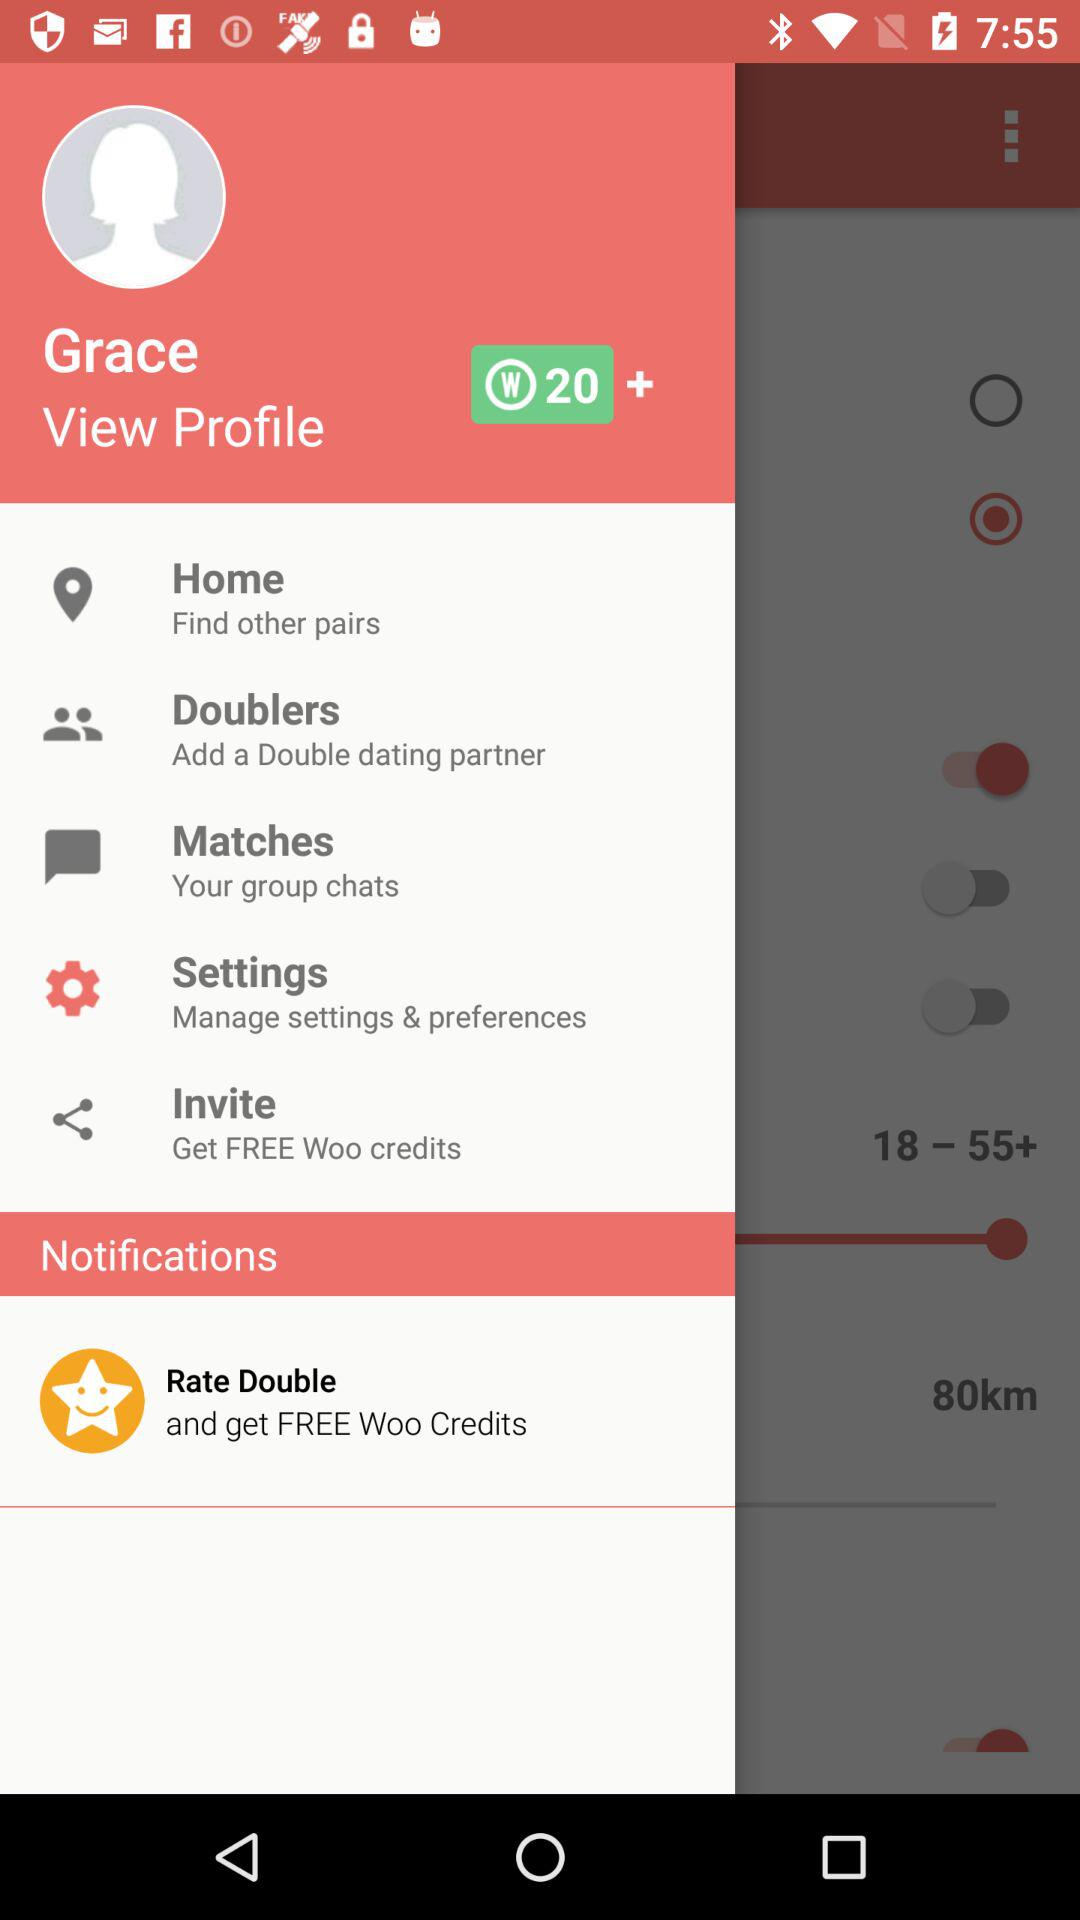What is the name of the user? The name of the user is Grace. 